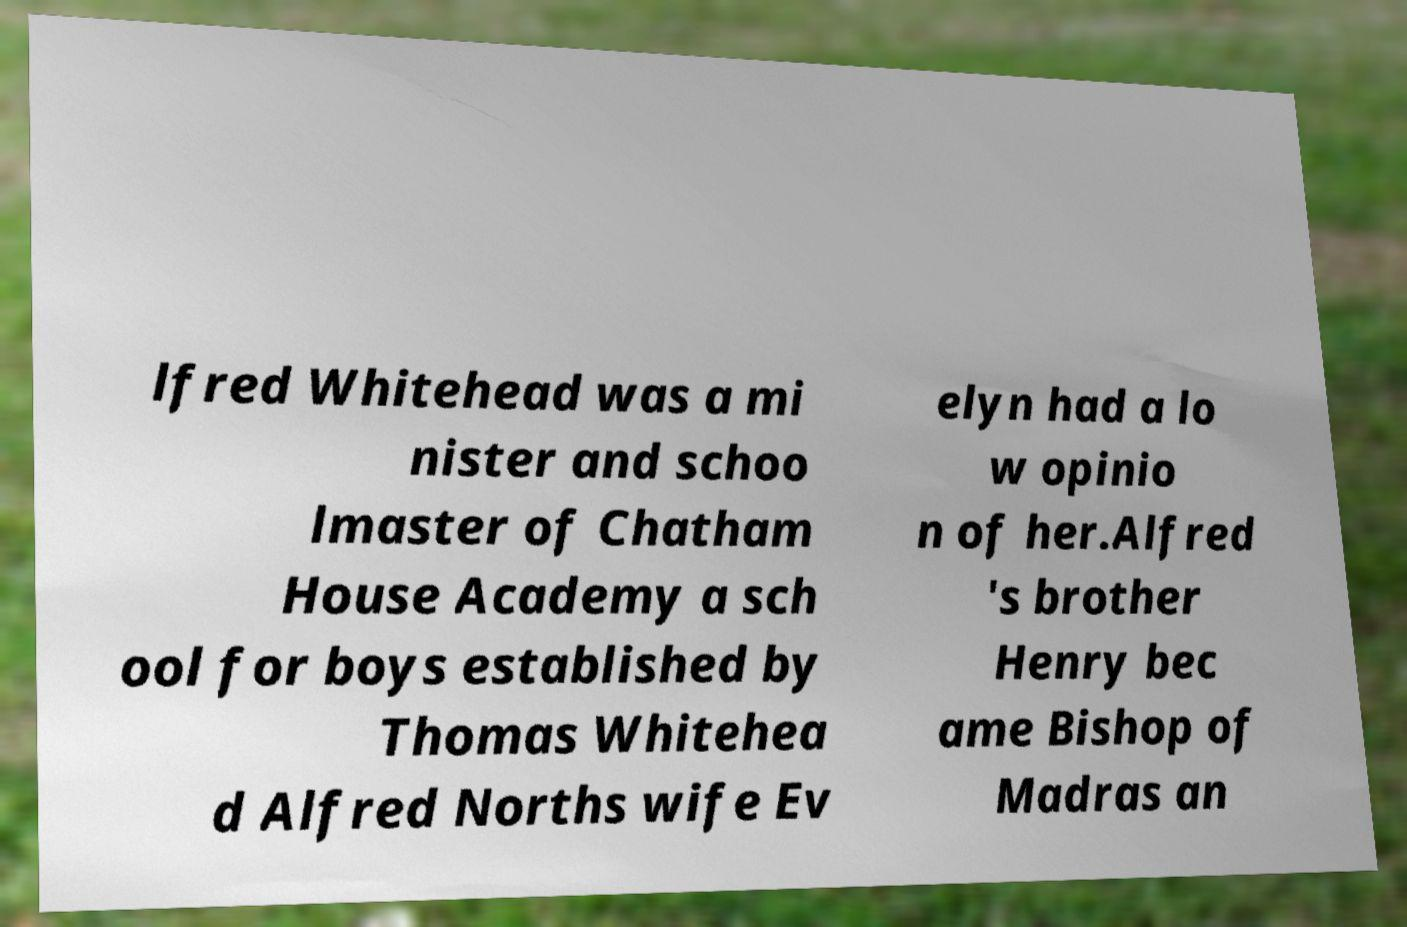I need the written content from this picture converted into text. Can you do that? lfred Whitehead was a mi nister and schoo lmaster of Chatham House Academy a sch ool for boys established by Thomas Whitehea d Alfred Norths wife Ev elyn had a lo w opinio n of her.Alfred 's brother Henry bec ame Bishop of Madras an 